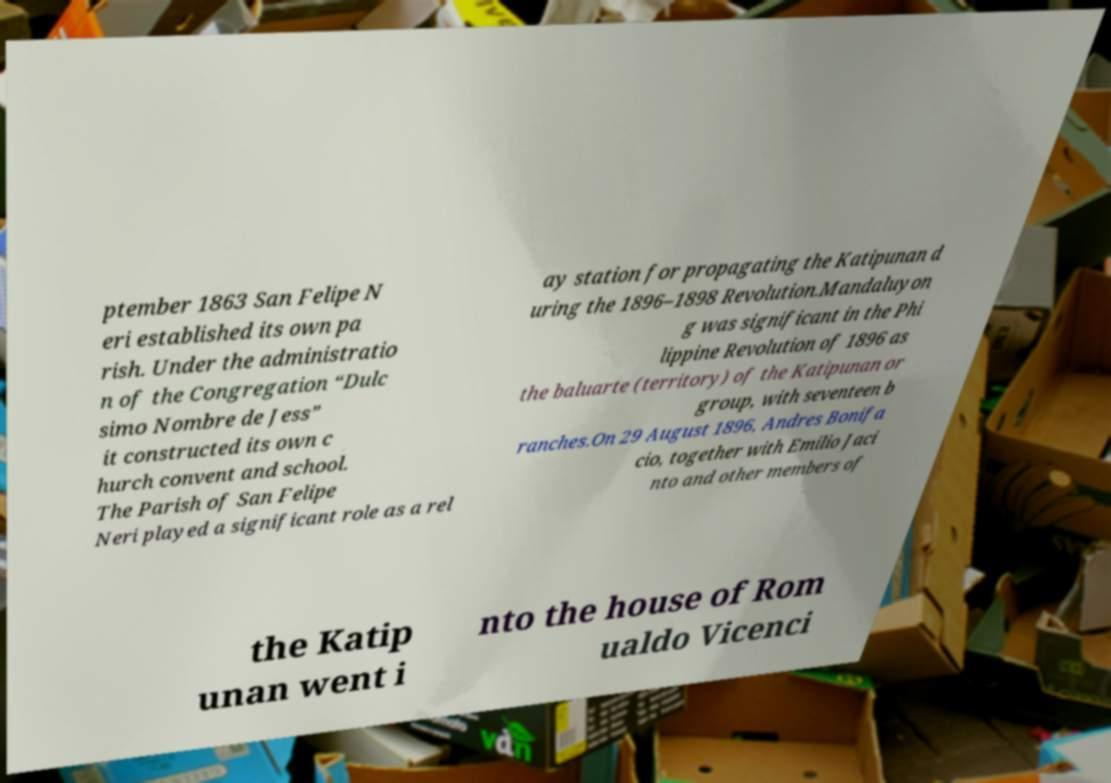There's text embedded in this image that I need extracted. Can you transcribe it verbatim? ptember 1863 San Felipe N eri established its own pa rish. Under the administratio n of the Congregation “Dulc simo Nombre de Jess” it constructed its own c hurch convent and school. The Parish of San Felipe Neri played a significant role as a rel ay station for propagating the Katipunan d uring the 1896–1898 Revolution.Mandaluyon g was significant in the Phi lippine Revolution of 1896 as the baluarte (territory) of the Katipunan or group, with seventeen b ranches.On 29 August 1896, Andres Bonifa cio, together with Emilio Jaci nto and other members of the Katip unan went i nto the house of Rom ualdo Vicenci 